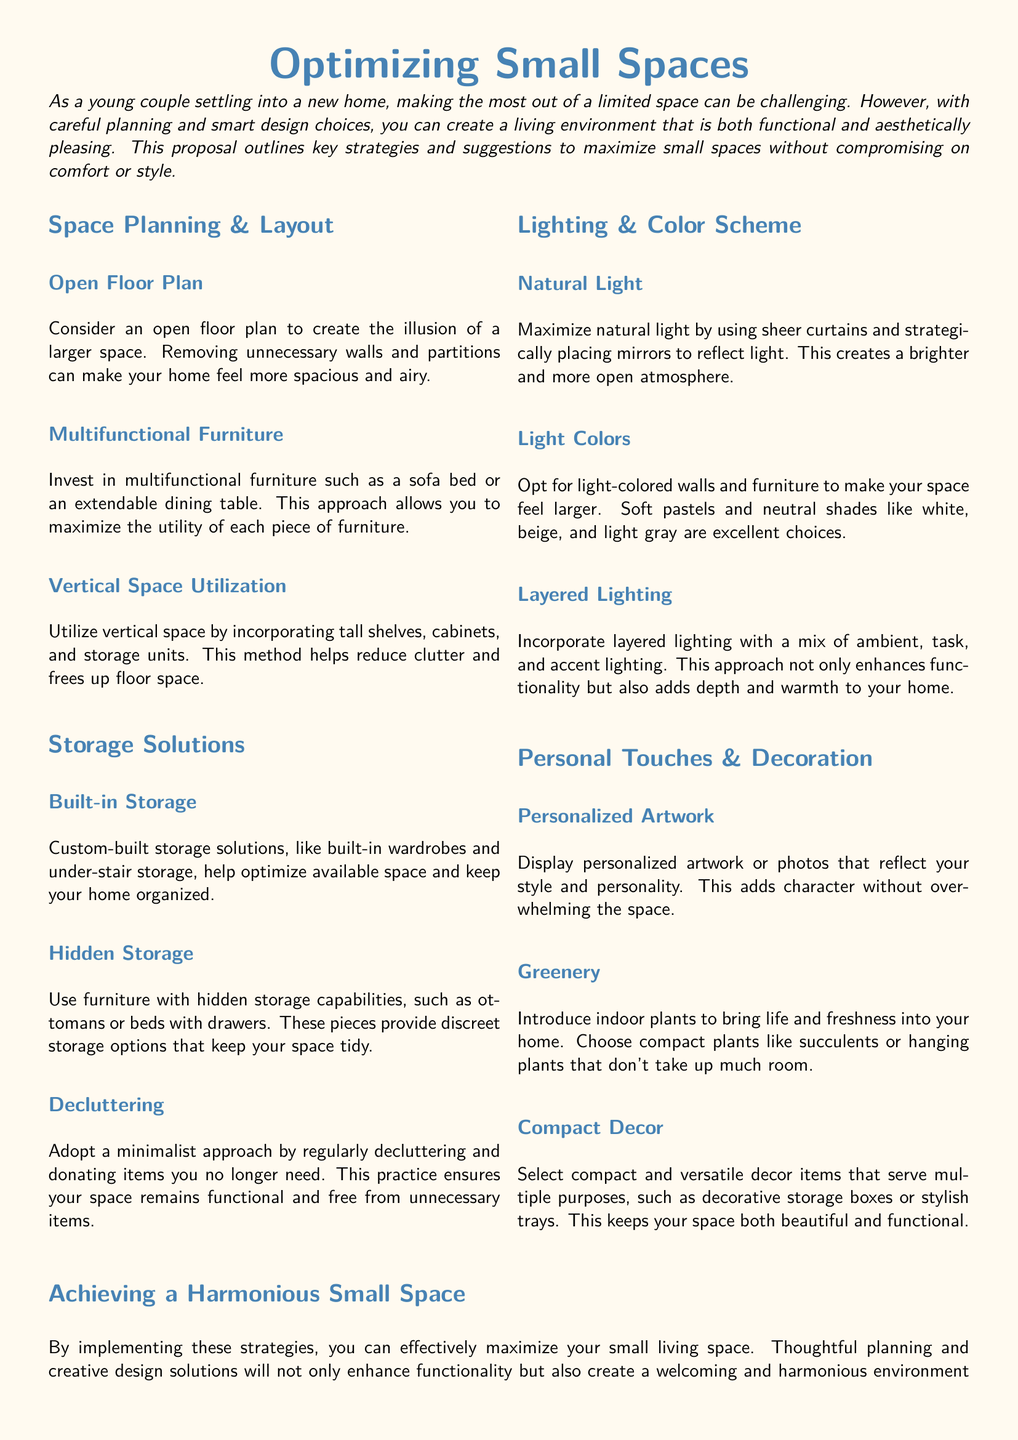What is the title of the proposal? The title provides a clear understanding of the document's focus on storage solutions and space optimization.
Answer: Optimizing Small Spaces What color scheme is recommended for the walls? The document suggests using light colors to enhance the perception of space.
Answer: Light-colored What type of furniture is suggested for maximizing space? Multifunctional furniture can serve different purposes, which is essential for small spaces.
Answer: Multifunctional furniture How many sections are there in the document? The document is divided into distinct sections, each addressing different strategies for space optimization.
Answer: Four What strategy is suggested for utilizing vertical space? Utilizing vertical space effectively can help reduce clutter and maximize utility.
Answer: Incorporating tall shelves What is one way to maximize natural light? The document discusses methods to enhance the brightness of a small space through light manipulation.
Answer: Sheer curtains What is recommended for decluttering? Regular decluttering is emphasized as a way to maintain an organized living space.
Answer: Donate items What kind of plants are suggested? The document recommends incorporating plants that are suitable for smaller spaces.
Answer: Compact plants What type of lighting should be incorporated for functionality? The document highlights the importance of different lighting types to enhance atmosphere.
Answer: Layered lighting What decorative element adds character without overwhelming the space? The document suggests using artwork to personalize the home while maintaining aesthetics.
Answer: Personalized artwork 